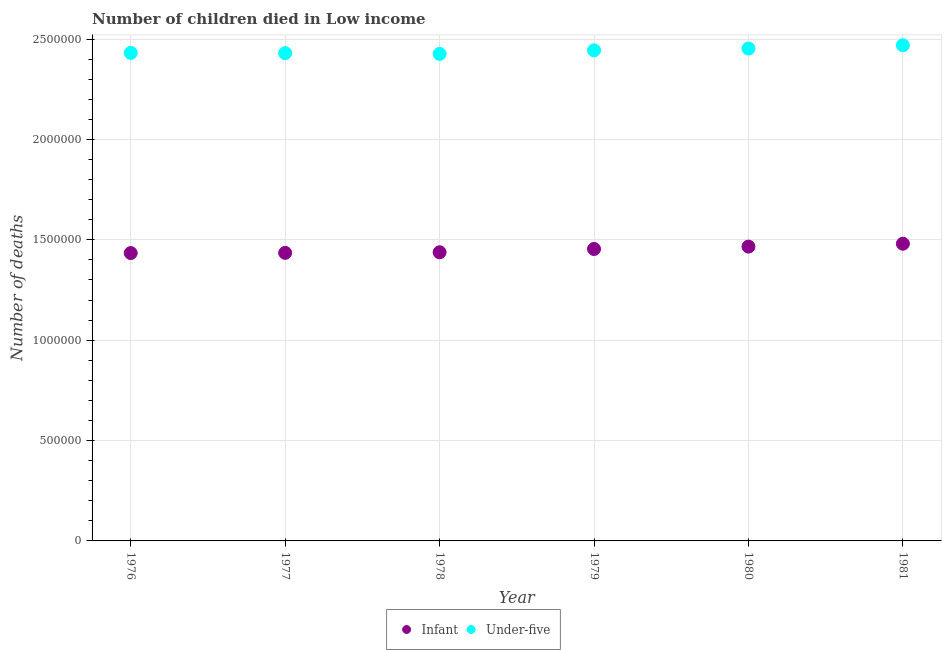How many different coloured dotlines are there?
Offer a very short reply. 2. Is the number of dotlines equal to the number of legend labels?
Offer a very short reply. Yes. What is the number of under-five deaths in 1976?
Your answer should be compact. 2.43e+06. Across all years, what is the maximum number of under-five deaths?
Make the answer very short. 2.47e+06. Across all years, what is the minimum number of infant deaths?
Offer a very short reply. 1.43e+06. In which year was the number of under-five deaths maximum?
Your answer should be compact. 1981. In which year was the number of under-five deaths minimum?
Give a very brief answer. 1978. What is the total number of under-five deaths in the graph?
Your answer should be very brief. 1.47e+07. What is the difference between the number of under-five deaths in 1979 and that in 1981?
Provide a short and direct response. -2.53e+04. What is the difference between the number of infant deaths in 1978 and the number of under-five deaths in 1976?
Ensure brevity in your answer.  -9.93e+05. What is the average number of infant deaths per year?
Ensure brevity in your answer.  1.45e+06. In the year 1981, what is the difference between the number of under-five deaths and number of infant deaths?
Your answer should be very brief. 9.88e+05. What is the ratio of the number of under-five deaths in 1976 to that in 1978?
Provide a succinct answer. 1. Is the number of under-five deaths in 1976 less than that in 1977?
Provide a short and direct response. No. Is the difference between the number of infant deaths in 1979 and 1980 greater than the difference between the number of under-five deaths in 1979 and 1980?
Offer a terse response. No. What is the difference between the highest and the second highest number of infant deaths?
Ensure brevity in your answer.  1.45e+04. What is the difference between the highest and the lowest number of under-five deaths?
Your response must be concise. 4.30e+04. In how many years, is the number of infant deaths greater than the average number of infant deaths taken over all years?
Offer a very short reply. 3. Is the sum of the number of infant deaths in 1977 and 1978 greater than the maximum number of under-five deaths across all years?
Your answer should be compact. Yes. Does the number of under-five deaths monotonically increase over the years?
Your answer should be compact. No. How many dotlines are there?
Provide a succinct answer. 2. What is the difference between two consecutive major ticks on the Y-axis?
Offer a very short reply. 5.00e+05. Where does the legend appear in the graph?
Your answer should be compact. Bottom center. How many legend labels are there?
Ensure brevity in your answer.  2. What is the title of the graph?
Offer a terse response. Number of children died in Low income. What is the label or title of the Y-axis?
Provide a short and direct response. Number of deaths. What is the Number of deaths of Infant in 1976?
Offer a terse response. 1.43e+06. What is the Number of deaths in Under-five in 1976?
Your answer should be very brief. 2.43e+06. What is the Number of deaths of Infant in 1977?
Your response must be concise. 1.43e+06. What is the Number of deaths of Under-five in 1977?
Your answer should be compact. 2.43e+06. What is the Number of deaths of Infant in 1978?
Provide a short and direct response. 1.44e+06. What is the Number of deaths in Under-five in 1978?
Offer a terse response. 2.43e+06. What is the Number of deaths in Infant in 1979?
Your answer should be compact. 1.45e+06. What is the Number of deaths in Under-five in 1979?
Provide a short and direct response. 2.44e+06. What is the Number of deaths of Infant in 1980?
Offer a very short reply. 1.47e+06. What is the Number of deaths in Under-five in 1980?
Ensure brevity in your answer.  2.45e+06. What is the Number of deaths of Infant in 1981?
Keep it short and to the point. 1.48e+06. What is the Number of deaths of Under-five in 1981?
Make the answer very short. 2.47e+06. Across all years, what is the maximum Number of deaths of Infant?
Your response must be concise. 1.48e+06. Across all years, what is the maximum Number of deaths in Under-five?
Provide a short and direct response. 2.47e+06. Across all years, what is the minimum Number of deaths in Infant?
Give a very brief answer. 1.43e+06. Across all years, what is the minimum Number of deaths in Under-five?
Give a very brief answer. 2.43e+06. What is the total Number of deaths of Infant in the graph?
Your answer should be very brief. 8.71e+06. What is the total Number of deaths in Under-five in the graph?
Your response must be concise. 1.47e+07. What is the difference between the Number of deaths of Infant in 1976 and that in 1977?
Your answer should be compact. -1036. What is the difference between the Number of deaths of Under-five in 1976 and that in 1977?
Provide a succinct answer. 1364. What is the difference between the Number of deaths of Infant in 1976 and that in 1978?
Provide a short and direct response. -3983. What is the difference between the Number of deaths in Under-five in 1976 and that in 1978?
Your answer should be compact. 5091. What is the difference between the Number of deaths of Infant in 1976 and that in 1979?
Ensure brevity in your answer.  -2.03e+04. What is the difference between the Number of deaths of Under-five in 1976 and that in 1979?
Your answer should be very brief. -1.26e+04. What is the difference between the Number of deaths in Infant in 1976 and that in 1980?
Your response must be concise. -3.21e+04. What is the difference between the Number of deaths of Under-five in 1976 and that in 1980?
Make the answer very short. -2.17e+04. What is the difference between the Number of deaths in Infant in 1976 and that in 1981?
Give a very brief answer. -4.66e+04. What is the difference between the Number of deaths in Under-five in 1976 and that in 1981?
Give a very brief answer. -3.80e+04. What is the difference between the Number of deaths in Infant in 1977 and that in 1978?
Offer a very short reply. -2947. What is the difference between the Number of deaths in Under-five in 1977 and that in 1978?
Give a very brief answer. 3727. What is the difference between the Number of deaths in Infant in 1977 and that in 1979?
Your answer should be very brief. -1.93e+04. What is the difference between the Number of deaths of Under-five in 1977 and that in 1979?
Your answer should be very brief. -1.40e+04. What is the difference between the Number of deaths of Infant in 1977 and that in 1980?
Your answer should be very brief. -3.11e+04. What is the difference between the Number of deaths in Under-five in 1977 and that in 1980?
Give a very brief answer. -2.31e+04. What is the difference between the Number of deaths in Infant in 1977 and that in 1981?
Your response must be concise. -4.56e+04. What is the difference between the Number of deaths in Under-five in 1977 and that in 1981?
Your answer should be compact. -3.93e+04. What is the difference between the Number of deaths in Infant in 1978 and that in 1979?
Provide a short and direct response. -1.63e+04. What is the difference between the Number of deaths in Under-five in 1978 and that in 1979?
Ensure brevity in your answer.  -1.77e+04. What is the difference between the Number of deaths of Infant in 1978 and that in 1980?
Your answer should be very brief. -2.81e+04. What is the difference between the Number of deaths of Under-five in 1978 and that in 1980?
Your response must be concise. -2.68e+04. What is the difference between the Number of deaths in Infant in 1978 and that in 1981?
Your response must be concise. -4.27e+04. What is the difference between the Number of deaths in Under-five in 1978 and that in 1981?
Provide a succinct answer. -4.30e+04. What is the difference between the Number of deaths in Infant in 1979 and that in 1980?
Your answer should be very brief. -1.18e+04. What is the difference between the Number of deaths in Under-five in 1979 and that in 1980?
Your answer should be very brief. -9067. What is the difference between the Number of deaths of Infant in 1979 and that in 1981?
Give a very brief answer. -2.63e+04. What is the difference between the Number of deaths of Under-five in 1979 and that in 1981?
Ensure brevity in your answer.  -2.53e+04. What is the difference between the Number of deaths of Infant in 1980 and that in 1981?
Provide a short and direct response. -1.45e+04. What is the difference between the Number of deaths of Under-five in 1980 and that in 1981?
Provide a succinct answer. -1.63e+04. What is the difference between the Number of deaths of Infant in 1976 and the Number of deaths of Under-five in 1977?
Give a very brief answer. -9.96e+05. What is the difference between the Number of deaths of Infant in 1976 and the Number of deaths of Under-five in 1978?
Ensure brevity in your answer.  -9.92e+05. What is the difference between the Number of deaths in Infant in 1976 and the Number of deaths in Under-five in 1979?
Offer a terse response. -1.01e+06. What is the difference between the Number of deaths of Infant in 1976 and the Number of deaths of Under-five in 1980?
Your response must be concise. -1.02e+06. What is the difference between the Number of deaths of Infant in 1976 and the Number of deaths of Under-five in 1981?
Your response must be concise. -1.04e+06. What is the difference between the Number of deaths of Infant in 1977 and the Number of deaths of Under-five in 1978?
Provide a succinct answer. -9.91e+05. What is the difference between the Number of deaths in Infant in 1977 and the Number of deaths in Under-five in 1979?
Your answer should be compact. -1.01e+06. What is the difference between the Number of deaths in Infant in 1977 and the Number of deaths in Under-five in 1980?
Make the answer very short. -1.02e+06. What is the difference between the Number of deaths of Infant in 1977 and the Number of deaths of Under-five in 1981?
Offer a very short reply. -1.03e+06. What is the difference between the Number of deaths in Infant in 1978 and the Number of deaths in Under-five in 1979?
Offer a very short reply. -1.01e+06. What is the difference between the Number of deaths in Infant in 1978 and the Number of deaths in Under-five in 1980?
Your answer should be compact. -1.01e+06. What is the difference between the Number of deaths of Infant in 1978 and the Number of deaths of Under-five in 1981?
Keep it short and to the point. -1.03e+06. What is the difference between the Number of deaths in Infant in 1979 and the Number of deaths in Under-five in 1980?
Your answer should be compact. -9.99e+05. What is the difference between the Number of deaths of Infant in 1979 and the Number of deaths of Under-five in 1981?
Make the answer very short. -1.01e+06. What is the difference between the Number of deaths of Infant in 1980 and the Number of deaths of Under-five in 1981?
Your answer should be compact. -1.00e+06. What is the average Number of deaths of Infant per year?
Give a very brief answer. 1.45e+06. What is the average Number of deaths in Under-five per year?
Your answer should be compact. 2.44e+06. In the year 1976, what is the difference between the Number of deaths of Infant and Number of deaths of Under-five?
Provide a succinct answer. -9.97e+05. In the year 1977, what is the difference between the Number of deaths of Infant and Number of deaths of Under-five?
Provide a short and direct response. -9.95e+05. In the year 1978, what is the difference between the Number of deaths of Infant and Number of deaths of Under-five?
Give a very brief answer. -9.88e+05. In the year 1979, what is the difference between the Number of deaths in Infant and Number of deaths in Under-five?
Keep it short and to the point. -9.89e+05. In the year 1980, what is the difference between the Number of deaths of Infant and Number of deaths of Under-five?
Provide a short and direct response. -9.87e+05. In the year 1981, what is the difference between the Number of deaths in Infant and Number of deaths in Under-five?
Your response must be concise. -9.88e+05. What is the ratio of the Number of deaths in Under-five in 1976 to that in 1977?
Provide a short and direct response. 1. What is the ratio of the Number of deaths of Under-five in 1976 to that in 1978?
Make the answer very short. 1. What is the ratio of the Number of deaths in Infant in 1976 to that in 1979?
Offer a terse response. 0.99. What is the ratio of the Number of deaths in Under-five in 1976 to that in 1979?
Your answer should be compact. 0.99. What is the ratio of the Number of deaths in Infant in 1976 to that in 1980?
Your response must be concise. 0.98. What is the ratio of the Number of deaths in Infant in 1976 to that in 1981?
Offer a terse response. 0.97. What is the ratio of the Number of deaths of Under-five in 1976 to that in 1981?
Provide a succinct answer. 0.98. What is the ratio of the Number of deaths of Infant in 1977 to that in 1979?
Make the answer very short. 0.99. What is the ratio of the Number of deaths in Infant in 1977 to that in 1980?
Your answer should be very brief. 0.98. What is the ratio of the Number of deaths of Under-five in 1977 to that in 1980?
Offer a terse response. 0.99. What is the ratio of the Number of deaths of Infant in 1977 to that in 1981?
Provide a succinct answer. 0.97. What is the ratio of the Number of deaths in Under-five in 1977 to that in 1981?
Your answer should be very brief. 0.98. What is the ratio of the Number of deaths in Infant in 1978 to that in 1980?
Your response must be concise. 0.98. What is the ratio of the Number of deaths of Infant in 1978 to that in 1981?
Your answer should be very brief. 0.97. What is the ratio of the Number of deaths of Under-five in 1978 to that in 1981?
Offer a terse response. 0.98. What is the ratio of the Number of deaths in Infant in 1979 to that in 1980?
Your answer should be very brief. 0.99. What is the ratio of the Number of deaths of Under-five in 1979 to that in 1980?
Make the answer very short. 1. What is the ratio of the Number of deaths of Infant in 1979 to that in 1981?
Provide a succinct answer. 0.98. What is the ratio of the Number of deaths of Under-five in 1979 to that in 1981?
Provide a succinct answer. 0.99. What is the ratio of the Number of deaths in Infant in 1980 to that in 1981?
Make the answer very short. 0.99. What is the ratio of the Number of deaths in Under-five in 1980 to that in 1981?
Offer a terse response. 0.99. What is the difference between the highest and the second highest Number of deaths in Infant?
Your response must be concise. 1.45e+04. What is the difference between the highest and the second highest Number of deaths of Under-five?
Offer a very short reply. 1.63e+04. What is the difference between the highest and the lowest Number of deaths of Infant?
Give a very brief answer. 4.66e+04. What is the difference between the highest and the lowest Number of deaths in Under-five?
Provide a short and direct response. 4.30e+04. 